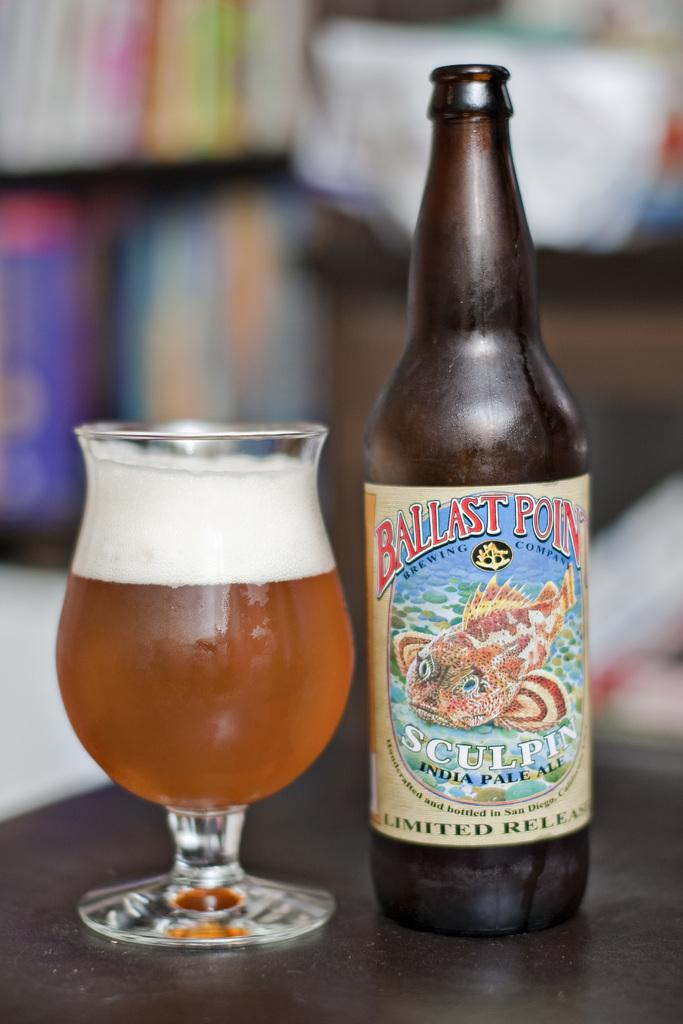<image>
Relay a brief, clear account of the picture shown. A Ballast Point bottle is next to a glass of beer. 